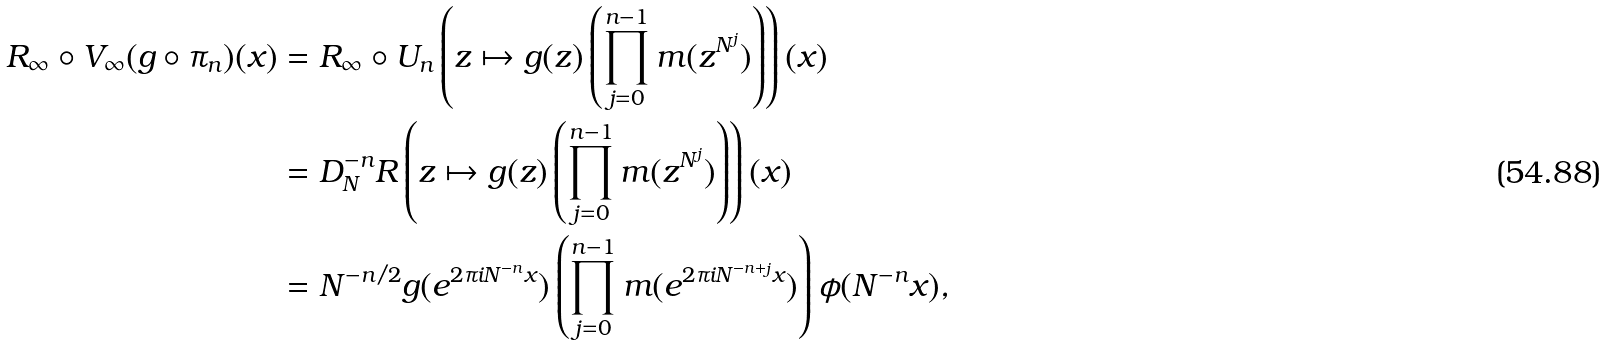Convert formula to latex. <formula><loc_0><loc_0><loc_500><loc_500>R _ { \infty } \circ V _ { \infty } ( g \circ \pi _ { n } ) ( x ) & = R _ { \infty } \circ U _ { n } \left ( z \mapsto g ( z ) \left ( \prod _ { j = 0 } ^ { n - 1 } m ( z ^ { N ^ { j } } ) \right ) \right ) ( x ) \\ & = D _ { N } ^ { - n } R \left ( z \mapsto g ( z ) \left ( \prod _ { j = 0 } ^ { n - 1 } m ( z ^ { N ^ { j } } ) \right ) \right ) ( x ) \\ & = N ^ { - n / 2 } g ( e ^ { 2 \pi i N ^ { - n } x } ) \left ( \prod _ { j = 0 } ^ { n - 1 } m ( e ^ { 2 \pi i N ^ { - n + j } x } ) \right ) \phi ( N ^ { - n } x ) ,</formula> 